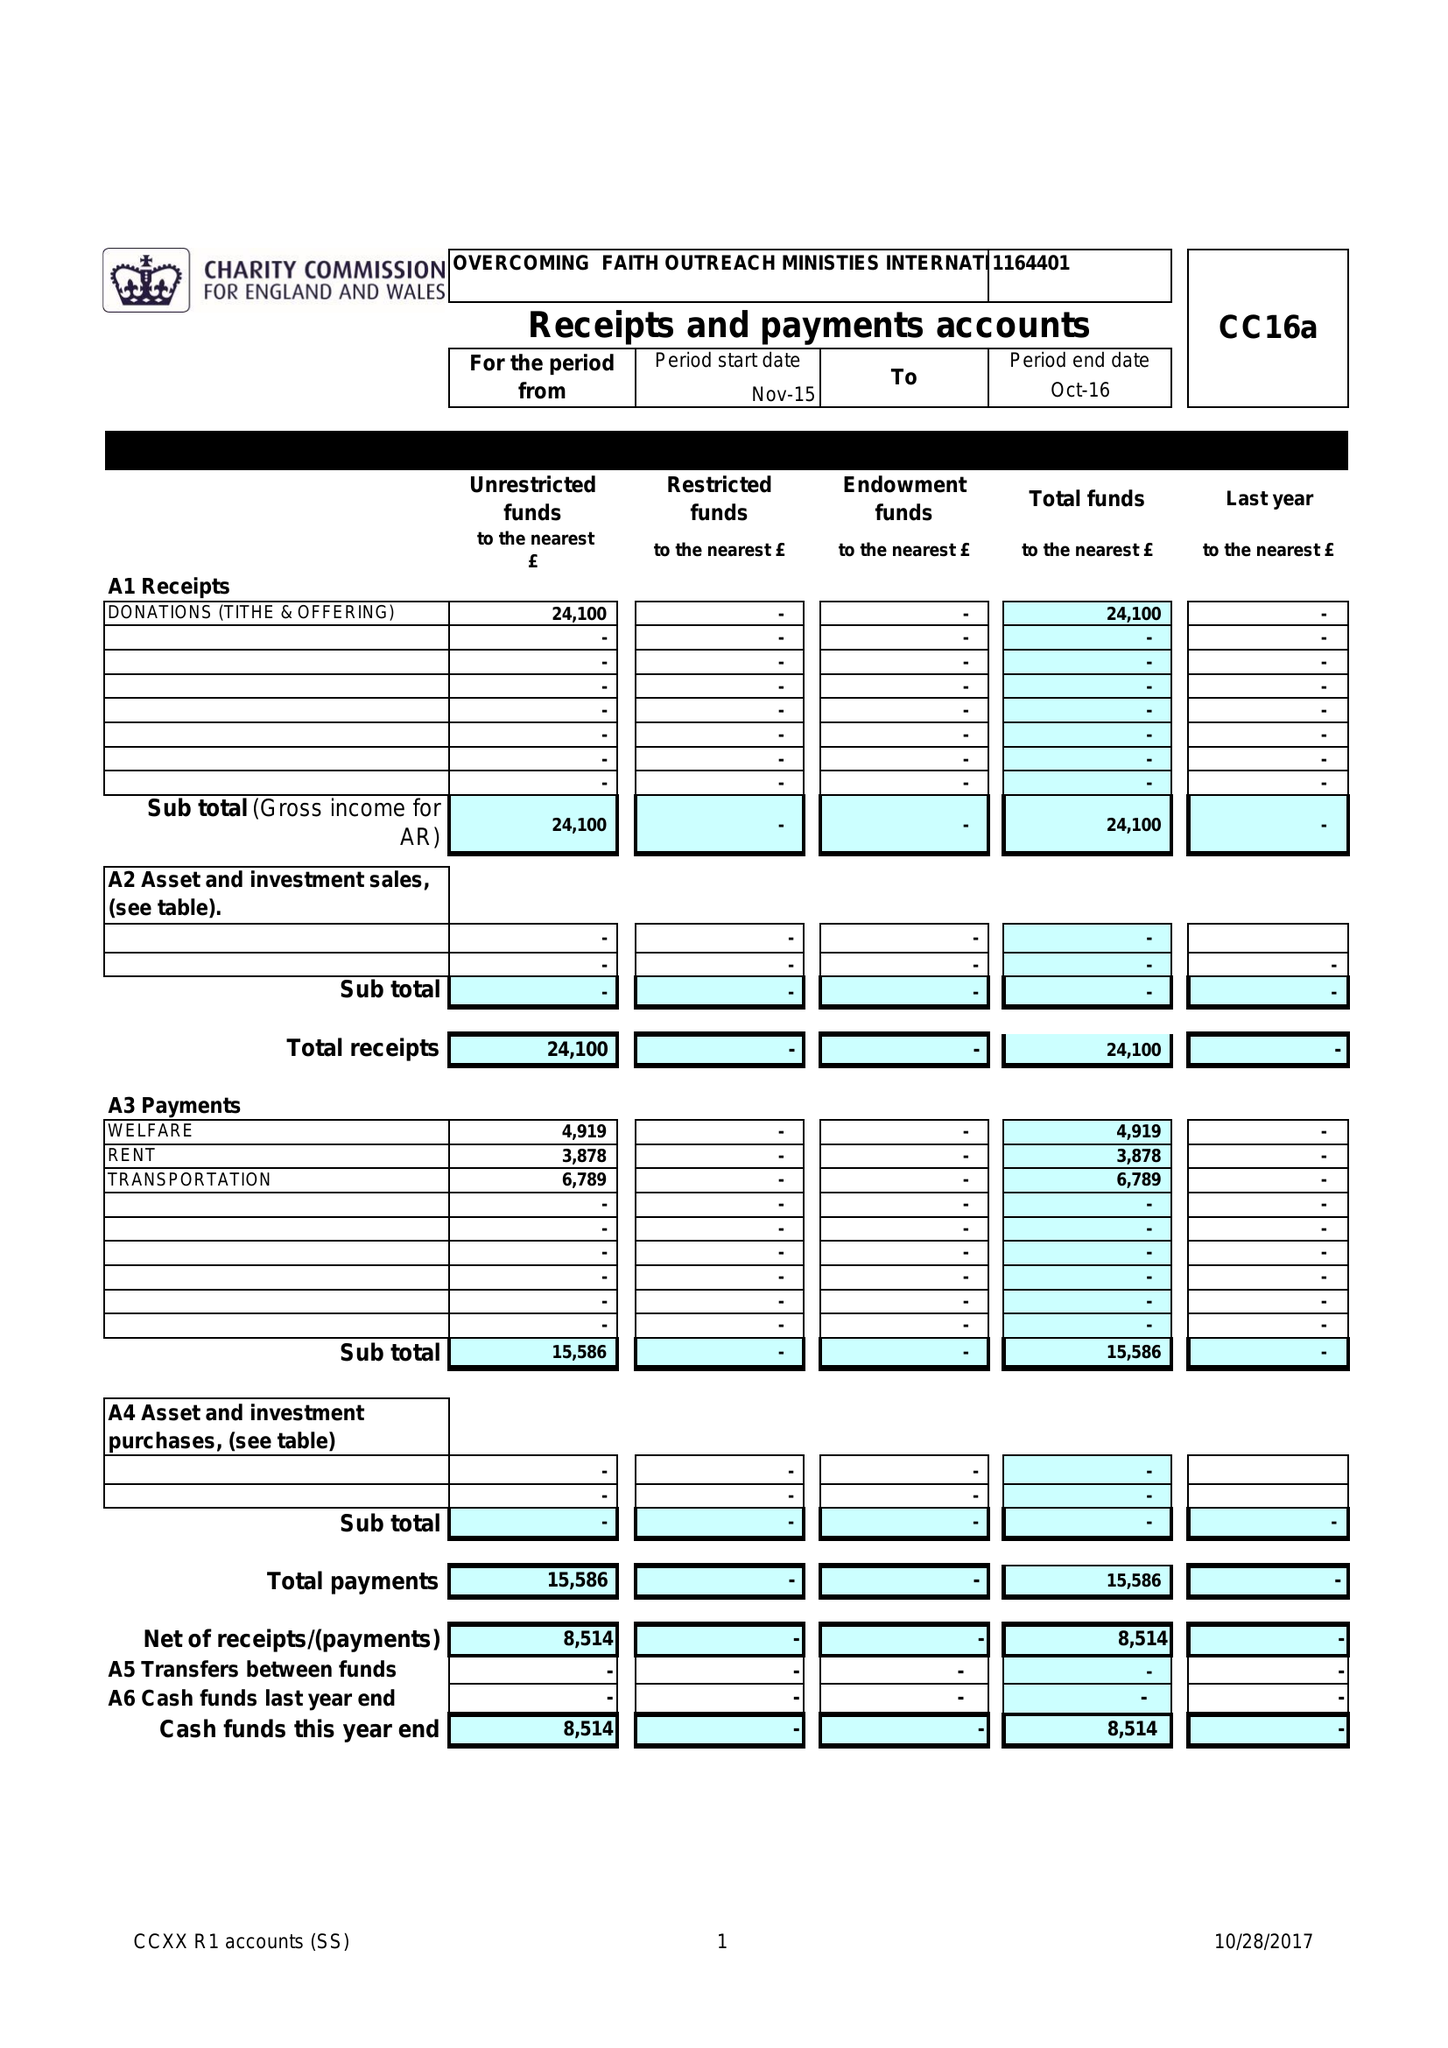What is the value for the report_date?
Answer the question using a single word or phrase. 2016-10-31 